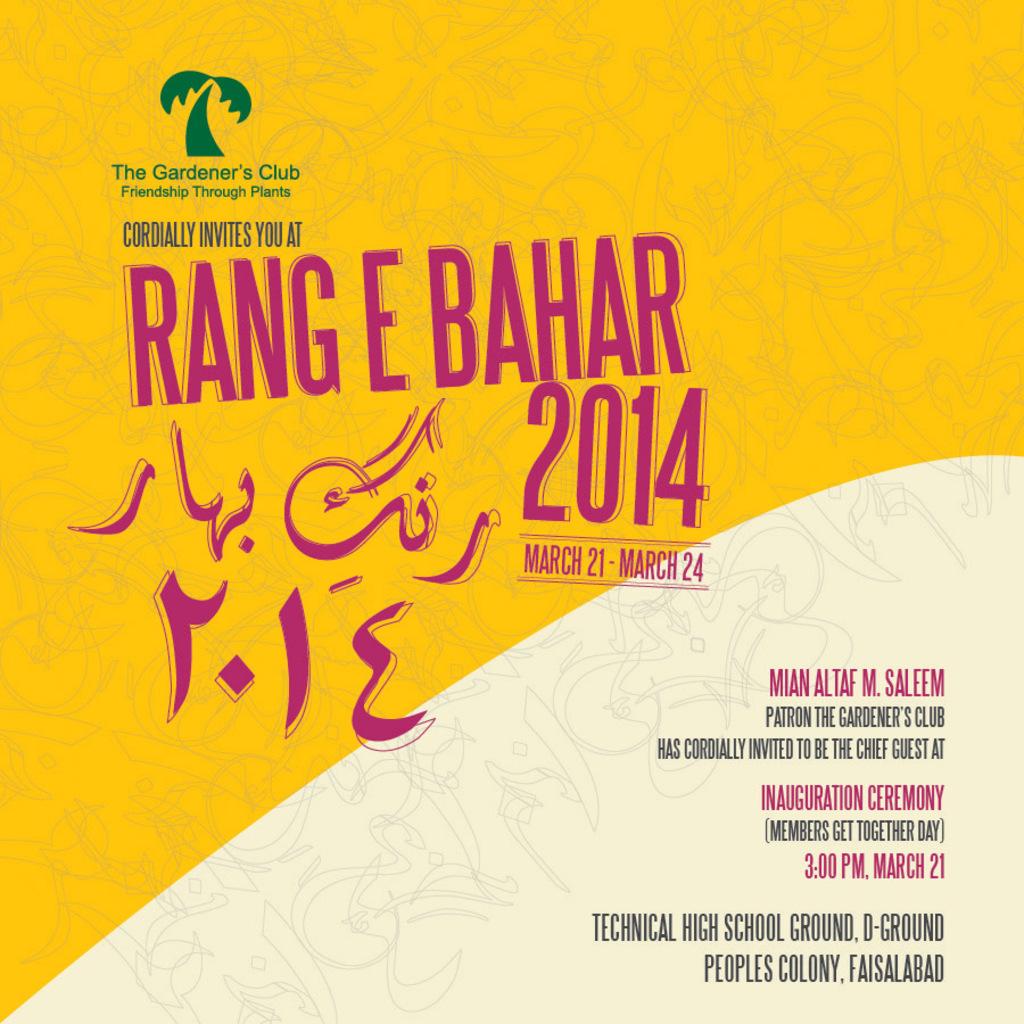What is this ad promoting?
Make the answer very short. Rang e bahar 2014. What year is provided in this ad?
Give a very brief answer. 2014. 